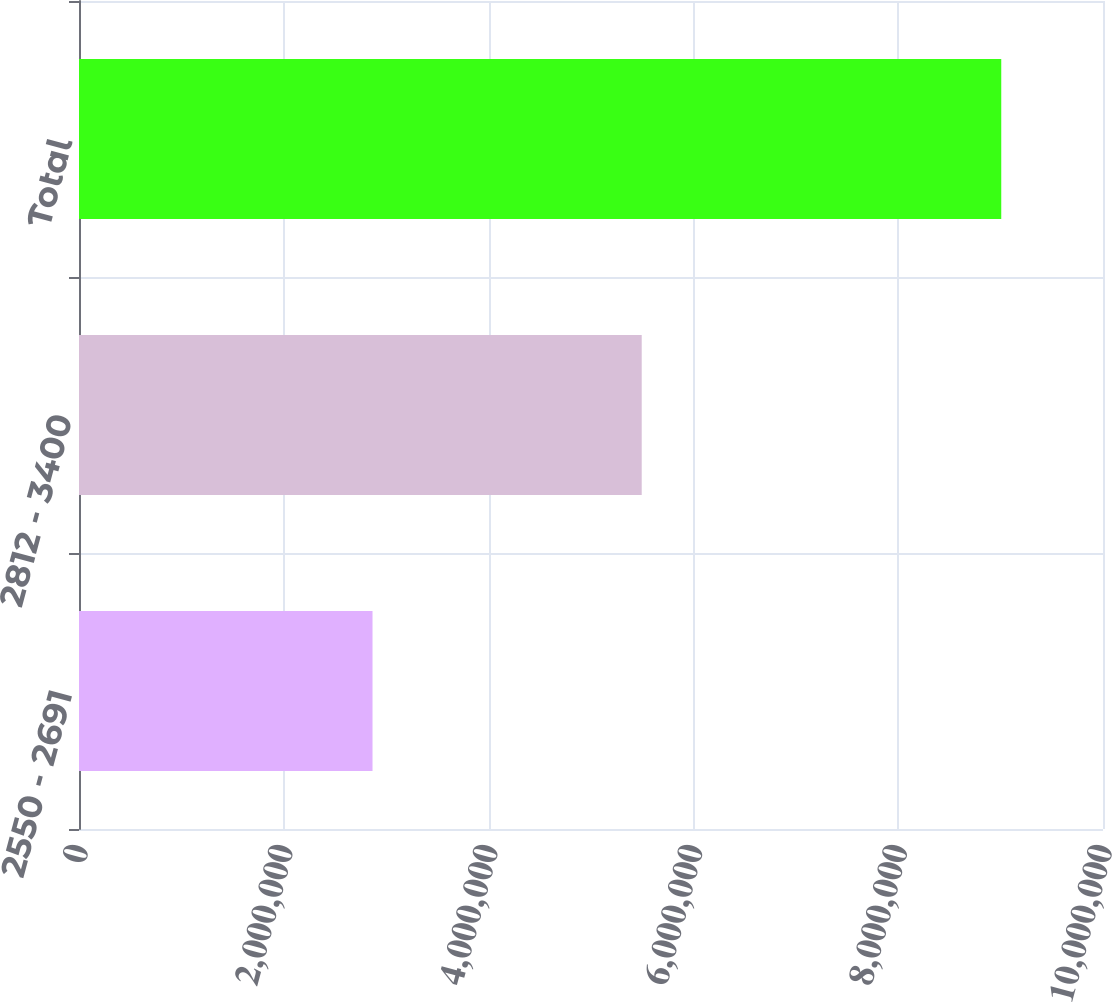Convert chart. <chart><loc_0><loc_0><loc_500><loc_500><bar_chart><fcel>2550 - 2691<fcel>2812 - 3400<fcel>Total<nl><fcel>2.8664e+06<fcel>5.49528e+06<fcel>9.00638e+06<nl></chart> 